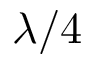Convert formula to latex. <formula><loc_0><loc_0><loc_500><loc_500>\lambda / 4</formula> 